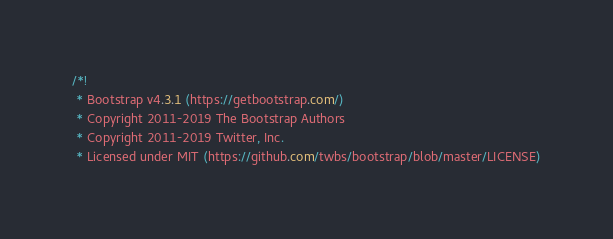<code> <loc_0><loc_0><loc_500><loc_500><_CSS_>/*!
 * Bootstrap v4.3.1 (https://getbootstrap.com/)
 * Copyright 2011-2019 The Bootstrap Authors
 * Copyright 2011-2019 Twitter, Inc.
 * Licensed under MIT (https://github.com/twbs/bootstrap/blob/master/LICENSE)</code> 